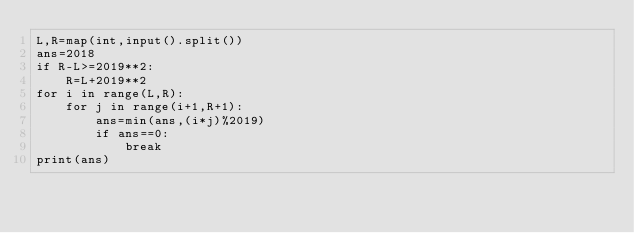<code> <loc_0><loc_0><loc_500><loc_500><_Python_>L,R=map(int,input().split())
ans=2018
if R-L>=2019**2:
    R=L+2019**2
for i in range(L,R):
    for j in range(i+1,R+1):
        ans=min(ans,(i*j)%2019)
        if ans==0:
            break
print(ans)</code> 